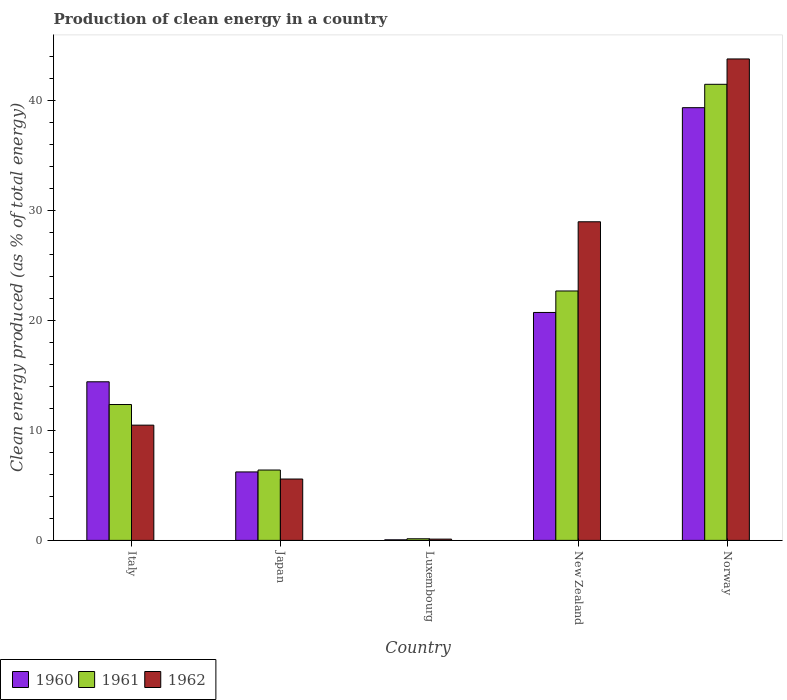How many different coloured bars are there?
Provide a short and direct response. 3. How many groups of bars are there?
Give a very brief answer. 5. What is the label of the 5th group of bars from the left?
Ensure brevity in your answer.  Norway. In how many cases, is the number of bars for a given country not equal to the number of legend labels?
Your answer should be compact. 0. What is the percentage of clean energy produced in 1962 in Italy?
Your answer should be very brief. 10.48. Across all countries, what is the maximum percentage of clean energy produced in 1962?
Keep it short and to the point. 43.77. Across all countries, what is the minimum percentage of clean energy produced in 1961?
Offer a very short reply. 0.15. In which country was the percentage of clean energy produced in 1962 maximum?
Make the answer very short. Norway. In which country was the percentage of clean energy produced in 1961 minimum?
Give a very brief answer. Luxembourg. What is the total percentage of clean energy produced in 1961 in the graph?
Your response must be concise. 83.03. What is the difference between the percentage of clean energy produced in 1961 in Luxembourg and that in New Zealand?
Keep it short and to the point. -22.53. What is the difference between the percentage of clean energy produced in 1961 in Norway and the percentage of clean energy produced in 1960 in Luxembourg?
Provide a short and direct response. 41.41. What is the average percentage of clean energy produced in 1961 per country?
Your answer should be very brief. 16.61. What is the difference between the percentage of clean energy produced of/in 1960 and percentage of clean energy produced of/in 1962 in New Zealand?
Keep it short and to the point. -8.24. What is the ratio of the percentage of clean energy produced in 1961 in Italy to that in New Zealand?
Provide a short and direct response. 0.54. Is the percentage of clean energy produced in 1960 in Italy less than that in Norway?
Make the answer very short. Yes. Is the difference between the percentage of clean energy produced in 1960 in Italy and Norway greater than the difference between the percentage of clean energy produced in 1962 in Italy and Norway?
Give a very brief answer. Yes. What is the difference between the highest and the second highest percentage of clean energy produced in 1960?
Your response must be concise. 6.3. What is the difference between the highest and the lowest percentage of clean energy produced in 1961?
Offer a terse response. 41.31. Is it the case that in every country, the sum of the percentage of clean energy produced in 1961 and percentage of clean energy produced in 1960 is greater than the percentage of clean energy produced in 1962?
Your response must be concise. Yes. Are the values on the major ticks of Y-axis written in scientific E-notation?
Offer a very short reply. No. Does the graph contain any zero values?
Offer a terse response. No. Does the graph contain grids?
Offer a terse response. No. What is the title of the graph?
Provide a short and direct response. Production of clean energy in a country. What is the label or title of the X-axis?
Provide a short and direct response. Country. What is the label or title of the Y-axis?
Your answer should be compact. Clean energy produced (as % of total energy). What is the Clean energy produced (as % of total energy) of 1960 in Italy?
Provide a short and direct response. 14.42. What is the Clean energy produced (as % of total energy) of 1961 in Italy?
Offer a very short reply. 12.35. What is the Clean energy produced (as % of total energy) in 1962 in Italy?
Offer a very short reply. 10.48. What is the Clean energy produced (as % of total energy) of 1960 in Japan?
Your answer should be compact. 6.22. What is the Clean energy produced (as % of total energy) of 1961 in Japan?
Your answer should be very brief. 6.4. What is the Clean energy produced (as % of total energy) of 1962 in Japan?
Offer a very short reply. 5.58. What is the Clean energy produced (as % of total energy) in 1960 in Luxembourg?
Offer a very short reply. 0.05. What is the Clean energy produced (as % of total energy) of 1961 in Luxembourg?
Your response must be concise. 0.15. What is the Clean energy produced (as % of total energy) in 1962 in Luxembourg?
Make the answer very short. 0.12. What is the Clean energy produced (as % of total energy) of 1960 in New Zealand?
Keep it short and to the point. 20.72. What is the Clean energy produced (as % of total energy) in 1961 in New Zealand?
Offer a very short reply. 22.67. What is the Clean energy produced (as % of total energy) in 1962 in New Zealand?
Ensure brevity in your answer.  28.96. What is the Clean energy produced (as % of total energy) of 1960 in Norway?
Make the answer very short. 39.34. What is the Clean energy produced (as % of total energy) of 1961 in Norway?
Your answer should be compact. 41.46. What is the Clean energy produced (as % of total energy) of 1962 in Norway?
Your answer should be compact. 43.77. Across all countries, what is the maximum Clean energy produced (as % of total energy) in 1960?
Offer a very short reply. 39.34. Across all countries, what is the maximum Clean energy produced (as % of total energy) in 1961?
Your answer should be compact. 41.46. Across all countries, what is the maximum Clean energy produced (as % of total energy) in 1962?
Ensure brevity in your answer.  43.77. Across all countries, what is the minimum Clean energy produced (as % of total energy) of 1960?
Keep it short and to the point. 0.05. Across all countries, what is the minimum Clean energy produced (as % of total energy) in 1961?
Offer a terse response. 0.15. Across all countries, what is the minimum Clean energy produced (as % of total energy) of 1962?
Offer a very short reply. 0.12. What is the total Clean energy produced (as % of total energy) of 1960 in the graph?
Ensure brevity in your answer.  80.75. What is the total Clean energy produced (as % of total energy) in 1961 in the graph?
Keep it short and to the point. 83.03. What is the total Clean energy produced (as % of total energy) of 1962 in the graph?
Your response must be concise. 88.9. What is the difference between the Clean energy produced (as % of total energy) of 1960 in Italy and that in Japan?
Ensure brevity in your answer.  8.19. What is the difference between the Clean energy produced (as % of total energy) of 1961 in Italy and that in Japan?
Your response must be concise. 5.95. What is the difference between the Clean energy produced (as % of total energy) of 1962 in Italy and that in Japan?
Provide a succinct answer. 4.9. What is the difference between the Clean energy produced (as % of total energy) of 1960 in Italy and that in Luxembourg?
Make the answer very short. 14.37. What is the difference between the Clean energy produced (as % of total energy) of 1961 in Italy and that in Luxembourg?
Offer a very short reply. 12.2. What is the difference between the Clean energy produced (as % of total energy) of 1962 in Italy and that in Luxembourg?
Keep it short and to the point. 10.36. What is the difference between the Clean energy produced (as % of total energy) in 1960 in Italy and that in New Zealand?
Keep it short and to the point. -6.3. What is the difference between the Clean energy produced (as % of total energy) in 1961 in Italy and that in New Zealand?
Give a very brief answer. -10.32. What is the difference between the Clean energy produced (as % of total energy) in 1962 in Italy and that in New Zealand?
Provide a short and direct response. -18.49. What is the difference between the Clean energy produced (as % of total energy) of 1960 in Italy and that in Norway?
Your answer should be very brief. -24.92. What is the difference between the Clean energy produced (as % of total energy) of 1961 in Italy and that in Norway?
Offer a terse response. -29.11. What is the difference between the Clean energy produced (as % of total energy) in 1962 in Italy and that in Norway?
Make the answer very short. -33.29. What is the difference between the Clean energy produced (as % of total energy) in 1960 in Japan and that in Luxembourg?
Your response must be concise. 6.17. What is the difference between the Clean energy produced (as % of total energy) in 1961 in Japan and that in Luxembourg?
Give a very brief answer. 6.25. What is the difference between the Clean energy produced (as % of total energy) of 1962 in Japan and that in Luxembourg?
Make the answer very short. 5.46. What is the difference between the Clean energy produced (as % of total energy) in 1960 in Japan and that in New Zealand?
Provide a succinct answer. -14.5. What is the difference between the Clean energy produced (as % of total energy) in 1961 in Japan and that in New Zealand?
Keep it short and to the point. -16.28. What is the difference between the Clean energy produced (as % of total energy) of 1962 in Japan and that in New Zealand?
Your answer should be very brief. -23.38. What is the difference between the Clean energy produced (as % of total energy) of 1960 in Japan and that in Norway?
Your answer should be compact. -33.11. What is the difference between the Clean energy produced (as % of total energy) of 1961 in Japan and that in Norway?
Provide a short and direct response. -35.06. What is the difference between the Clean energy produced (as % of total energy) in 1962 in Japan and that in Norway?
Offer a terse response. -38.19. What is the difference between the Clean energy produced (as % of total energy) of 1960 in Luxembourg and that in New Zealand?
Provide a succinct answer. -20.67. What is the difference between the Clean energy produced (as % of total energy) of 1961 in Luxembourg and that in New Zealand?
Your response must be concise. -22.53. What is the difference between the Clean energy produced (as % of total energy) of 1962 in Luxembourg and that in New Zealand?
Offer a very short reply. -28.85. What is the difference between the Clean energy produced (as % of total energy) of 1960 in Luxembourg and that in Norway?
Keep it short and to the point. -39.28. What is the difference between the Clean energy produced (as % of total energy) of 1961 in Luxembourg and that in Norway?
Provide a succinct answer. -41.31. What is the difference between the Clean energy produced (as % of total energy) of 1962 in Luxembourg and that in Norway?
Give a very brief answer. -43.65. What is the difference between the Clean energy produced (as % of total energy) of 1960 in New Zealand and that in Norway?
Your answer should be compact. -18.62. What is the difference between the Clean energy produced (as % of total energy) in 1961 in New Zealand and that in Norway?
Keep it short and to the point. -18.79. What is the difference between the Clean energy produced (as % of total energy) in 1962 in New Zealand and that in Norway?
Ensure brevity in your answer.  -14.8. What is the difference between the Clean energy produced (as % of total energy) of 1960 in Italy and the Clean energy produced (as % of total energy) of 1961 in Japan?
Offer a terse response. 8.02. What is the difference between the Clean energy produced (as % of total energy) in 1960 in Italy and the Clean energy produced (as % of total energy) in 1962 in Japan?
Make the answer very short. 8.84. What is the difference between the Clean energy produced (as % of total energy) in 1961 in Italy and the Clean energy produced (as % of total energy) in 1962 in Japan?
Ensure brevity in your answer.  6.77. What is the difference between the Clean energy produced (as % of total energy) in 1960 in Italy and the Clean energy produced (as % of total energy) in 1961 in Luxembourg?
Provide a succinct answer. 14.27. What is the difference between the Clean energy produced (as % of total energy) in 1960 in Italy and the Clean energy produced (as % of total energy) in 1962 in Luxembourg?
Keep it short and to the point. 14.3. What is the difference between the Clean energy produced (as % of total energy) of 1961 in Italy and the Clean energy produced (as % of total energy) of 1962 in Luxembourg?
Offer a very short reply. 12.23. What is the difference between the Clean energy produced (as % of total energy) of 1960 in Italy and the Clean energy produced (as % of total energy) of 1961 in New Zealand?
Give a very brief answer. -8.26. What is the difference between the Clean energy produced (as % of total energy) of 1960 in Italy and the Clean energy produced (as % of total energy) of 1962 in New Zealand?
Ensure brevity in your answer.  -14.55. What is the difference between the Clean energy produced (as % of total energy) in 1961 in Italy and the Clean energy produced (as % of total energy) in 1962 in New Zealand?
Ensure brevity in your answer.  -16.61. What is the difference between the Clean energy produced (as % of total energy) in 1960 in Italy and the Clean energy produced (as % of total energy) in 1961 in Norway?
Offer a very short reply. -27.04. What is the difference between the Clean energy produced (as % of total energy) of 1960 in Italy and the Clean energy produced (as % of total energy) of 1962 in Norway?
Provide a short and direct response. -29.35. What is the difference between the Clean energy produced (as % of total energy) of 1961 in Italy and the Clean energy produced (as % of total energy) of 1962 in Norway?
Ensure brevity in your answer.  -31.41. What is the difference between the Clean energy produced (as % of total energy) in 1960 in Japan and the Clean energy produced (as % of total energy) in 1961 in Luxembourg?
Your answer should be compact. 6.08. What is the difference between the Clean energy produced (as % of total energy) of 1960 in Japan and the Clean energy produced (as % of total energy) of 1962 in Luxembourg?
Provide a succinct answer. 6.11. What is the difference between the Clean energy produced (as % of total energy) in 1961 in Japan and the Clean energy produced (as % of total energy) in 1962 in Luxembourg?
Keep it short and to the point. 6.28. What is the difference between the Clean energy produced (as % of total energy) of 1960 in Japan and the Clean energy produced (as % of total energy) of 1961 in New Zealand?
Offer a terse response. -16.45. What is the difference between the Clean energy produced (as % of total energy) in 1960 in Japan and the Clean energy produced (as % of total energy) in 1962 in New Zealand?
Your response must be concise. -22.74. What is the difference between the Clean energy produced (as % of total energy) of 1961 in Japan and the Clean energy produced (as % of total energy) of 1962 in New Zealand?
Offer a terse response. -22.57. What is the difference between the Clean energy produced (as % of total energy) of 1960 in Japan and the Clean energy produced (as % of total energy) of 1961 in Norway?
Ensure brevity in your answer.  -35.24. What is the difference between the Clean energy produced (as % of total energy) of 1960 in Japan and the Clean energy produced (as % of total energy) of 1962 in Norway?
Keep it short and to the point. -37.54. What is the difference between the Clean energy produced (as % of total energy) of 1961 in Japan and the Clean energy produced (as % of total energy) of 1962 in Norway?
Keep it short and to the point. -37.37. What is the difference between the Clean energy produced (as % of total energy) of 1960 in Luxembourg and the Clean energy produced (as % of total energy) of 1961 in New Zealand?
Your response must be concise. -22.62. What is the difference between the Clean energy produced (as % of total energy) in 1960 in Luxembourg and the Clean energy produced (as % of total energy) in 1962 in New Zealand?
Your response must be concise. -28.91. What is the difference between the Clean energy produced (as % of total energy) of 1961 in Luxembourg and the Clean energy produced (as % of total energy) of 1962 in New Zealand?
Provide a short and direct response. -28.82. What is the difference between the Clean energy produced (as % of total energy) in 1960 in Luxembourg and the Clean energy produced (as % of total energy) in 1961 in Norway?
Ensure brevity in your answer.  -41.41. What is the difference between the Clean energy produced (as % of total energy) in 1960 in Luxembourg and the Clean energy produced (as % of total energy) in 1962 in Norway?
Offer a very short reply. -43.71. What is the difference between the Clean energy produced (as % of total energy) of 1961 in Luxembourg and the Clean energy produced (as % of total energy) of 1962 in Norway?
Offer a very short reply. -43.62. What is the difference between the Clean energy produced (as % of total energy) in 1960 in New Zealand and the Clean energy produced (as % of total energy) in 1961 in Norway?
Offer a very short reply. -20.74. What is the difference between the Clean energy produced (as % of total energy) of 1960 in New Zealand and the Clean energy produced (as % of total energy) of 1962 in Norway?
Offer a very short reply. -23.05. What is the difference between the Clean energy produced (as % of total energy) of 1961 in New Zealand and the Clean energy produced (as % of total energy) of 1962 in Norway?
Offer a very short reply. -21.09. What is the average Clean energy produced (as % of total energy) of 1960 per country?
Keep it short and to the point. 16.15. What is the average Clean energy produced (as % of total energy) in 1961 per country?
Your answer should be compact. 16.61. What is the average Clean energy produced (as % of total energy) of 1962 per country?
Offer a terse response. 17.78. What is the difference between the Clean energy produced (as % of total energy) in 1960 and Clean energy produced (as % of total energy) in 1961 in Italy?
Give a very brief answer. 2.07. What is the difference between the Clean energy produced (as % of total energy) of 1960 and Clean energy produced (as % of total energy) of 1962 in Italy?
Offer a terse response. 3.94. What is the difference between the Clean energy produced (as % of total energy) of 1961 and Clean energy produced (as % of total energy) of 1962 in Italy?
Provide a short and direct response. 1.87. What is the difference between the Clean energy produced (as % of total energy) in 1960 and Clean energy produced (as % of total energy) in 1961 in Japan?
Offer a terse response. -0.17. What is the difference between the Clean energy produced (as % of total energy) of 1960 and Clean energy produced (as % of total energy) of 1962 in Japan?
Ensure brevity in your answer.  0.64. What is the difference between the Clean energy produced (as % of total energy) in 1961 and Clean energy produced (as % of total energy) in 1962 in Japan?
Give a very brief answer. 0.82. What is the difference between the Clean energy produced (as % of total energy) in 1960 and Clean energy produced (as % of total energy) in 1961 in Luxembourg?
Your response must be concise. -0.09. What is the difference between the Clean energy produced (as % of total energy) in 1960 and Clean energy produced (as % of total energy) in 1962 in Luxembourg?
Offer a very short reply. -0.06. What is the difference between the Clean energy produced (as % of total energy) of 1961 and Clean energy produced (as % of total energy) of 1962 in Luxembourg?
Ensure brevity in your answer.  0.03. What is the difference between the Clean energy produced (as % of total energy) of 1960 and Clean energy produced (as % of total energy) of 1961 in New Zealand?
Provide a short and direct response. -1.95. What is the difference between the Clean energy produced (as % of total energy) of 1960 and Clean energy produced (as % of total energy) of 1962 in New Zealand?
Provide a short and direct response. -8.24. What is the difference between the Clean energy produced (as % of total energy) of 1961 and Clean energy produced (as % of total energy) of 1962 in New Zealand?
Ensure brevity in your answer.  -6.29. What is the difference between the Clean energy produced (as % of total energy) of 1960 and Clean energy produced (as % of total energy) of 1961 in Norway?
Your response must be concise. -2.12. What is the difference between the Clean energy produced (as % of total energy) of 1960 and Clean energy produced (as % of total energy) of 1962 in Norway?
Your answer should be very brief. -4.43. What is the difference between the Clean energy produced (as % of total energy) of 1961 and Clean energy produced (as % of total energy) of 1962 in Norway?
Your answer should be compact. -2.31. What is the ratio of the Clean energy produced (as % of total energy) of 1960 in Italy to that in Japan?
Your response must be concise. 2.32. What is the ratio of the Clean energy produced (as % of total energy) in 1961 in Italy to that in Japan?
Your answer should be compact. 1.93. What is the ratio of the Clean energy produced (as % of total energy) in 1962 in Italy to that in Japan?
Your response must be concise. 1.88. What is the ratio of the Clean energy produced (as % of total energy) of 1960 in Italy to that in Luxembourg?
Ensure brevity in your answer.  276.95. What is the ratio of the Clean energy produced (as % of total energy) of 1961 in Italy to that in Luxembourg?
Your answer should be very brief. 84.09. What is the ratio of the Clean energy produced (as % of total energy) of 1962 in Italy to that in Luxembourg?
Give a very brief answer. 90.43. What is the ratio of the Clean energy produced (as % of total energy) of 1960 in Italy to that in New Zealand?
Ensure brevity in your answer.  0.7. What is the ratio of the Clean energy produced (as % of total energy) in 1961 in Italy to that in New Zealand?
Make the answer very short. 0.54. What is the ratio of the Clean energy produced (as % of total energy) of 1962 in Italy to that in New Zealand?
Give a very brief answer. 0.36. What is the ratio of the Clean energy produced (as % of total energy) in 1960 in Italy to that in Norway?
Give a very brief answer. 0.37. What is the ratio of the Clean energy produced (as % of total energy) of 1961 in Italy to that in Norway?
Your answer should be very brief. 0.3. What is the ratio of the Clean energy produced (as % of total energy) in 1962 in Italy to that in Norway?
Your answer should be very brief. 0.24. What is the ratio of the Clean energy produced (as % of total energy) in 1960 in Japan to that in Luxembourg?
Give a very brief answer. 119.55. What is the ratio of the Clean energy produced (as % of total energy) of 1961 in Japan to that in Luxembourg?
Give a very brief answer. 43.55. What is the ratio of the Clean energy produced (as % of total energy) of 1962 in Japan to that in Luxembourg?
Give a very brief answer. 48.16. What is the ratio of the Clean energy produced (as % of total energy) in 1960 in Japan to that in New Zealand?
Offer a terse response. 0.3. What is the ratio of the Clean energy produced (as % of total energy) in 1961 in Japan to that in New Zealand?
Provide a short and direct response. 0.28. What is the ratio of the Clean energy produced (as % of total energy) in 1962 in Japan to that in New Zealand?
Keep it short and to the point. 0.19. What is the ratio of the Clean energy produced (as % of total energy) of 1960 in Japan to that in Norway?
Ensure brevity in your answer.  0.16. What is the ratio of the Clean energy produced (as % of total energy) of 1961 in Japan to that in Norway?
Make the answer very short. 0.15. What is the ratio of the Clean energy produced (as % of total energy) in 1962 in Japan to that in Norway?
Keep it short and to the point. 0.13. What is the ratio of the Clean energy produced (as % of total energy) in 1960 in Luxembourg to that in New Zealand?
Your answer should be very brief. 0. What is the ratio of the Clean energy produced (as % of total energy) in 1961 in Luxembourg to that in New Zealand?
Provide a short and direct response. 0.01. What is the ratio of the Clean energy produced (as % of total energy) of 1962 in Luxembourg to that in New Zealand?
Give a very brief answer. 0. What is the ratio of the Clean energy produced (as % of total energy) in 1960 in Luxembourg to that in Norway?
Offer a very short reply. 0. What is the ratio of the Clean energy produced (as % of total energy) in 1961 in Luxembourg to that in Norway?
Provide a short and direct response. 0. What is the ratio of the Clean energy produced (as % of total energy) of 1962 in Luxembourg to that in Norway?
Give a very brief answer. 0. What is the ratio of the Clean energy produced (as % of total energy) of 1960 in New Zealand to that in Norway?
Offer a very short reply. 0.53. What is the ratio of the Clean energy produced (as % of total energy) of 1961 in New Zealand to that in Norway?
Keep it short and to the point. 0.55. What is the ratio of the Clean energy produced (as % of total energy) in 1962 in New Zealand to that in Norway?
Offer a very short reply. 0.66. What is the difference between the highest and the second highest Clean energy produced (as % of total energy) in 1960?
Offer a very short reply. 18.62. What is the difference between the highest and the second highest Clean energy produced (as % of total energy) in 1961?
Provide a succinct answer. 18.79. What is the difference between the highest and the second highest Clean energy produced (as % of total energy) in 1962?
Ensure brevity in your answer.  14.8. What is the difference between the highest and the lowest Clean energy produced (as % of total energy) in 1960?
Offer a very short reply. 39.28. What is the difference between the highest and the lowest Clean energy produced (as % of total energy) of 1961?
Your response must be concise. 41.31. What is the difference between the highest and the lowest Clean energy produced (as % of total energy) in 1962?
Your response must be concise. 43.65. 